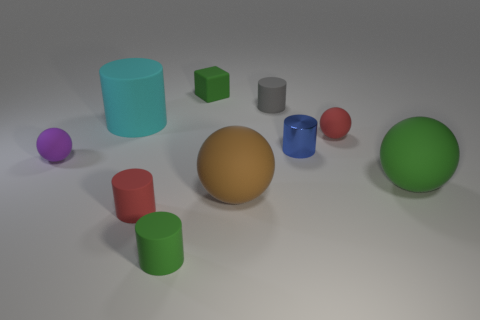Are there any other things that are made of the same material as the small blue object?
Ensure brevity in your answer.  No. There is a small rubber sphere that is to the left of the tiny gray thing; what number of green objects are behind it?
Offer a terse response. 1. Is the number of cylinders that are on the left side of the green cylinder greater than the number of blue shiny cylinders left of the cyan rubber cylinder?
Ensure brevity in your answer.  Yes. What material is the green cylinder?
Offer a terse response. Rubber. Are there any green matte balls of the same size as the cyan thing?
Keep it short and to the point. Yes. There is a brown sphere that is the same size as the cyan cylinder; what is it made of?
Your answer should be very brief. Rubber. What number of purple matte things are there?
Make the answer very short. 1. What is the size of the red object that is in front of the large green sphere?
Provide a short and direct response. Small. Is the number of green rubber spheres to the left of the small red ball the same as the number of rubber cylinders?
Your response must be concise. No. Are there any other big objects that have the same shape as the large brown thing?
Provide a short and direct response. Yes. 